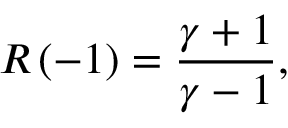Convert formula to latex. <formula><loc_0><loc_0><loc_500><loc_500>R \left ( - 1 \right ) = \frac { \gamma + 1 } { \gamma - 1 } ,</formula> 